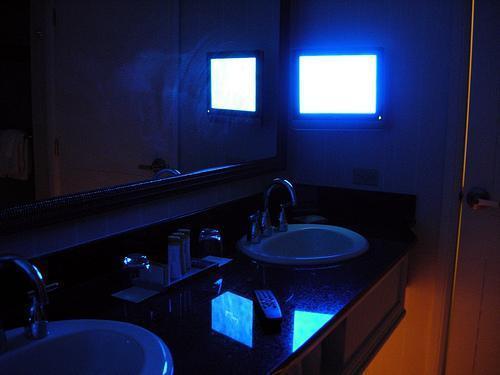How many windows are reflected?
Give a very brief answer. 1. How many tvs are there?
Give a very brief answer. 2. 